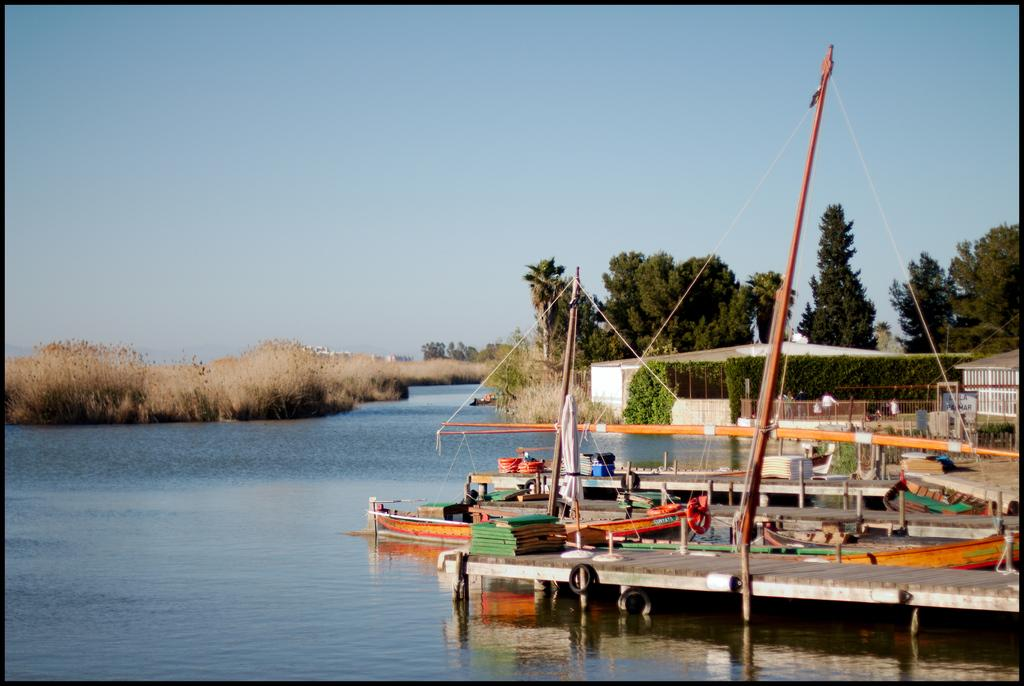What is the main structure in the image? There is a platform in the image. What can be seen in the water near the platform? There are boats in the water. What type of barrier is present in the image? There is a metal fence in the image. What is visible in the background of the image? Trees, buildings, and the sky are visible in the background of the image. How does the platform contribute to the digestion process in the image? The platform does not contribute to any digestion process in the image; it is a structure for other purposes. 